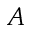<formula> <loc_0><loc_0><loc_500><loc_500>A</formula> 